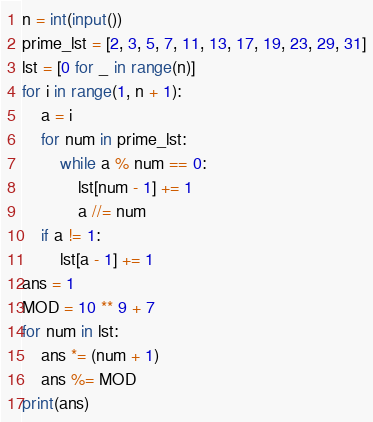<code> <loc_0><loc_0><loc_500><loc_500><_Python_>n = int(input())
prime_lst = [2, 3, 5, 7, 11, 13, 17, 19, 23, 29, 31]
lst = [0 for _ in range(n)]
for i in range(1, n + 1):
    a = i
    for num in prime_lst:
        while a % num == 0:
            lst[num - 1] += 1
            a //= num
    if a != 1:
        lst[a - 1] += 1
ans = 1
MOD = 10 ** 9 + 7
for num in lst:
    ans *= (num + 1)
    ans %= MOD
print(ans)</code> 